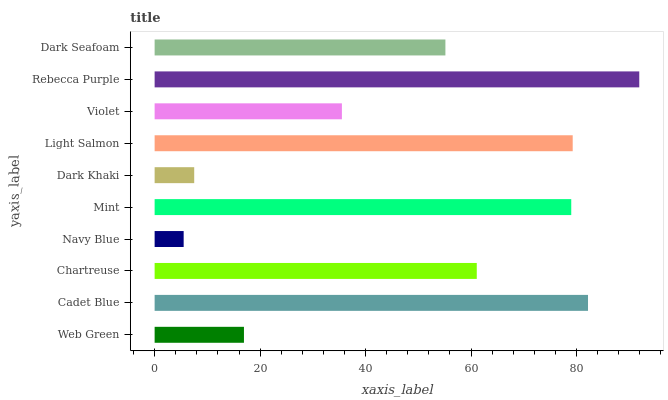Is Navy Blue the minimum?
Answer yes or no. Yes. Is Rebecca Purple the maximum?
Answer yes or no. Yes. Is Cadet Blue the minimum?
Answer yes or no. No. Is Cadet Blue the maximum?
Answer yes or no. No. Is Cadet Blue greater than Web Green?
Answer yes or no. Yes. Is Web Green less than Cadet Blue?
Answer yes or no. Yes. Is Web Green greater than Cadet Blue?
Answer yes or no. No. Is Cadet Blue less than Web Green?
Answer yes or no. No. Is Chartreuse the high median?
Answer yes or no. Yes. Is Dark Seafoam the low median?
Answer yes or no. Yes. Is Cadet Blue the high median?
Answer yes or no. No. Is Web Green the low median?
Answer yes or no. No. 